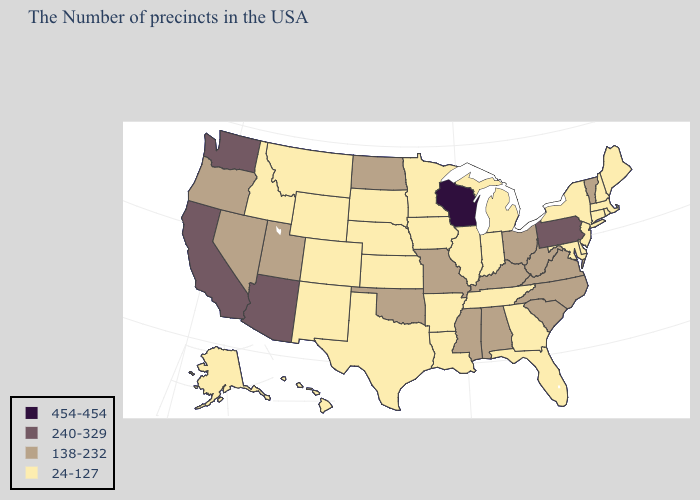Does Alabama have the same value as Georgia?
Quick response, please. No. Among the states that border South Dakota , does North Dakota have the lowest value?
Be succinct. No. Name the states that have a value in the range 24-127?
Concise answer only. Maine, Massachusetts, Rhode Island, New Hampshire, Connecticut, New York, New Jersey, Delaware, Maryland, Florida, Georgia, Michigan, Indiana, Tennessee, Illinois, Louisiana, Arkansas, Minnesota, Iowa, Kansas, Nebraska, Texas, South Dakota, Wyoming, Colorado, New Mexico, Montana, Idaho, Alaska, Hawaii. Does Tennessee have the same value as New Mexico?
Concise answer only. Yes. Which states have the lowest value in the South?
Be succinct. Delaware, Maryland, Florida, Georgia, Tennessee, Louisiana, Arkansas, Texas. What is the value of New Mexico?
Quick response, please. 24-127. Which states have the highest value in the USA?
Quick response, please. Wisconsin. What is the lowest value in the West?
Give a very brief answer. 24-127. Among the states that border Mississippi , which have the lowest value?
Concise answer only. Tennessee, Louisiana, Arkansas. What is the value of California?
Write a very short answer. 240-329. What is the value of Washington?
Concise answer only. 240-329. What is the lowest value in the USA?
Be succinct. 24-127. What is the lowest value in the USA?
Give a very brief answer. 24-127. Name the states that have a value in the range 24-127?
Write a very short answer. Maine, Massachusetts, Rhode Island, New Hampshire, Connecticut, New York, New Jersey, Delaware, Maryland, Florida, Georgia, Michigan, Indiana, Tennessee, Illinois, Louisiana, Arkansas, Minnesota, Iowa, Kansas, Nebraska, Texas, South Dakota, Wyoming, Colorado, New Mexico, Montana, Idaho, Alaska, Hawaii. How many symbols are there in the legend?
Write a very short answer. 4. 